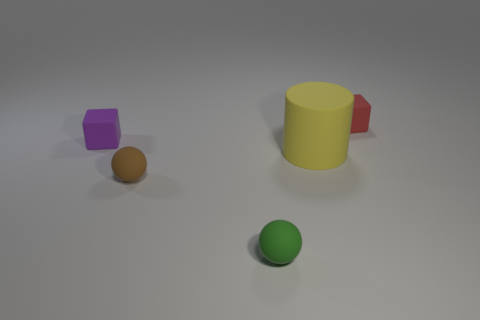Are any small matte blocks visible?
Give a very brief answer. Yes. What is the color of the rubber ball that is the same size as the green thing?
Your answer should be very brief. Brown. What number of other matte things have the same shape as the tiny red matte object?
Your answer should be compact. 1. Is the block that is to the left of the large cylinder made of the same material as the tiny green sphere?
Offer a very short reply. Yes. What number of cylinders are either tiny green things or brown matte things?
Your response must be concise. 0. What is the shape of the thing behind the matte block that is left of the small matte ball behind the tiny green matte ball?
Give a very brief answer. Cube. How many green objects are the same size as the yellow object?
Keep it short and to the point. 0. There is a cube that is behind the purple cube; is there a green sphere on the left side of it?
Make the answer very short. Yes. What number of objects are either small gray metallic spheres or large things?
Provide a succinct answer. 1. There is a big matte cylinder that is in front of the tiny cube left of the tiny rubber object that is right of the small green rubber ball; what color is it?
Your answer should be very brief. Yellow. 